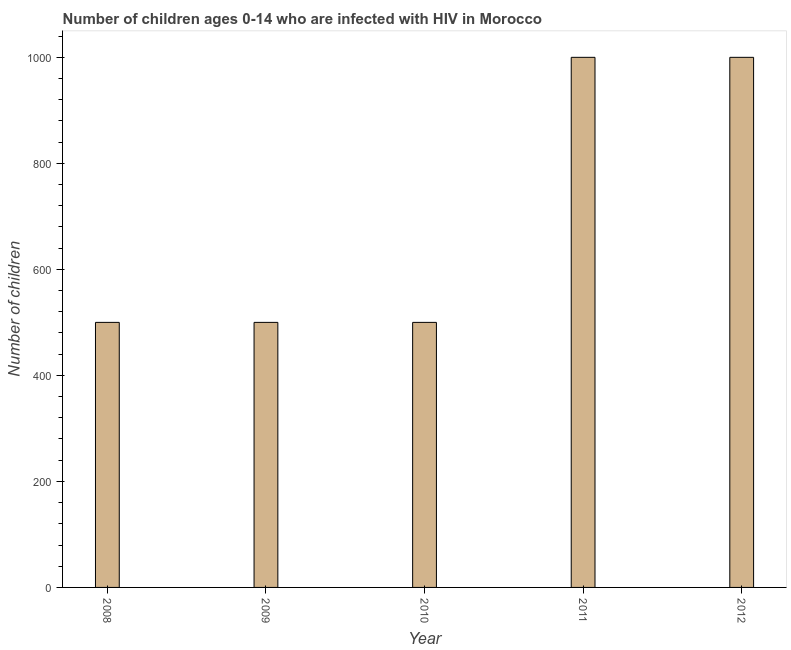What is the title of the graph?
Provide a succinct answer. Number of children ages 0-14 who are infected with HIV in Morocco. What is the label or title of the X-axis?
Ensure brevity in your answer.  Year. What is the label or title of the Y-axis?
Give a very brief answer. Number of children. Across all years, what is the maximum number of children living with hiv?
Keep it short and to the point. 1000. In which year was the number of children living with hiv minimum?
Give a very brief answer. 2008. What is the sum of the number of children living with hiv?
Your answer should be compact. 3500. What is the difference between the number of children living with hiv in 2010 and 2011?
Your response must be concise. -500. What is the average number of children living with hiv per year?
Keep it short and to the point. 700. In how many years, is the number of children living with hiv greater than 360 ?
Offer a terse response. 5. What is the ratio of the number of children living with hiv in 2010 to that in 2012?
Your response must be concise. 0.5. Is the number of children living with hiv in 2009 less than that in 2011?
Make the answer very short. Yes. What is the difference between the highest and the second highest number of children living with hiv?
Provide a short and direct response. 0. Is the sum of the number of children living with hiv in 2008 and 2011 greater than the maximum number of children living with hiv across all years?
Give a very brief answer. Yes. In how many years, is the number of children living with hiv greater than the average number of children living with hiv taken over all years?
Offer a terse response. 2. How many bars are there?
Make the answer very short. 5. How many years are there in the graph?
Ensure brevity in your answer.  5. What is the Number of children of 2008?
Offer a very short reply. 500. What is the Number of children of 2010?
Keep it short and to the point. 500. What is the Number of children of 2011?
Give a very brief answer. 1000. What is the difference between the Number of children in 2008 and 2011?
Provide a short and direct response. -500. What is the difference between the Number of children in 2008 and 2012?
Your response must be concise. -500. What is the difference between the Number of children in 2009 and 2011?
Ensure brevity in your answer.  -500. What is the difference between the Number of children in 2009 and 2012?
Your response must be concise. -500. What is the difference between the Number of children in 2010 and 2011?
Ensure brevity in your answer.  -500. What is the difference between the Number of children in 2010 and 2012?
Provide a succinct answer. -500. What is the difference between the Number of children in 2011 and 2012?
Ensure brevity in your answer.  0. What is the ratio of the Number of children in 2008 to that in 2009?
Ensure brevity in your answer.  1. What is the ratio of the Number of children in 2008 to that in 2012?
Your answer should be very brief. 0.5. What is the ratio of the Number of children in 2009 to that in 2011?
Your answer should be compact. 0.5. What is the ratio of the Number of children in 2010 to that in 2011?
Provide a succinct answer. 0.5. 